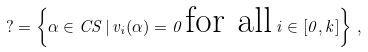<formula> <loc_0><loc_0><loc_500><loc_500>? = \left \{ \alpha \in C S \, | \, v _ { i } ( \alpha ) = 0 \, \text {for all} \, i \in \left [ 0 , k \right ] \right \} \, ,</formula> 